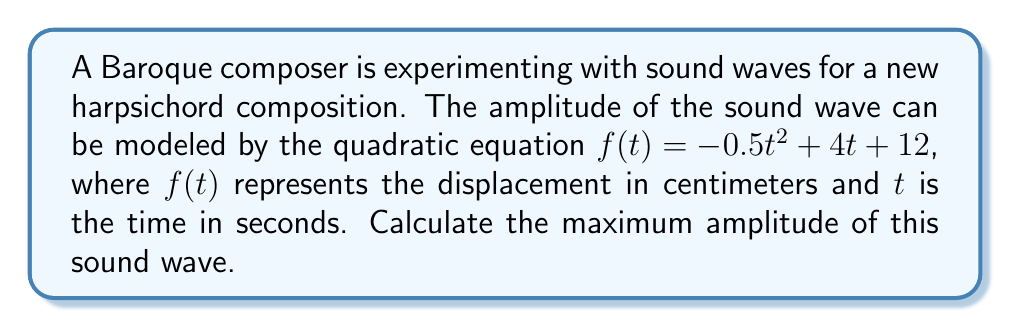What is the answer to this math problem? To find the maximum amplitude of the sound wave, we need to determine the vertex of the parabola represented by the quadratic equation. The steps are as follows:

1) The quadratic equation is in the form $f(t) = at^2 + bt + c$, where:
   $a = -0.5$
   $b = 4$
   $c = 12$

2) For a quadratic equation, the t-coordinate of the vertex is given by $t = -\frac{b}{2a}$:

   $t = -\frac{4}{2(-0.5)} = -\frac{4}{-1} = 4$

3) To find the maximum amplitude, we need to calculate $f(4)$:

   $f(4) = -0.5(4)^2 + 4(4) + 12$
   $= -0.5(16) + 16 + 12$
   $= -8 + 16 + 12$
   $= 20$

Therefore, the maximum amplitude occurs at $t = 4$ seconds and has a value of 20 centimeters.
Answer: 20 cm 